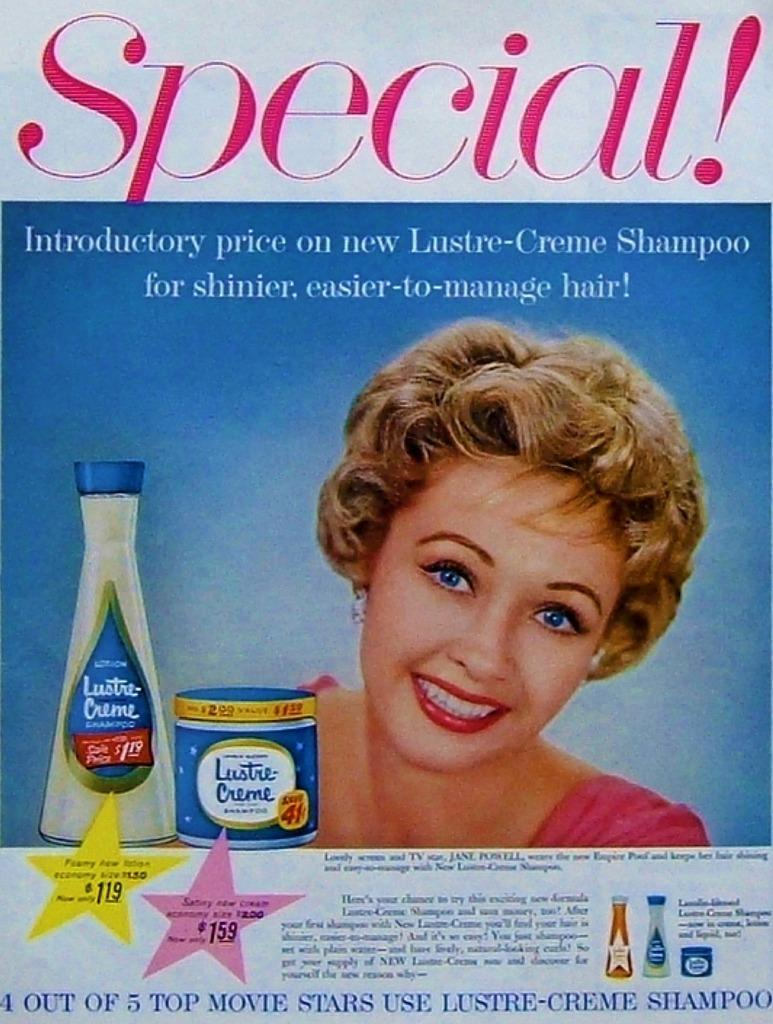<image>
Render a clear and concise summary of the photo. A smiling woman is in an ad for Lustre-Creme Shampoo. 